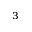Convert formula to latex. <formula><loc_0><loc_0><loc_500><loc_500>_ { 3 }</formula> 